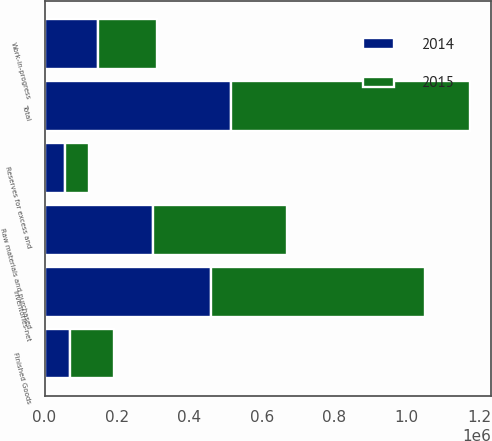Convert chart to OTSL. <chart><loc_0><loc_0><loc_500><loc_500><stacked_bar_chart><ecel><fcel>Raw materials and purchased<fcel>Work-in-progress<fcel>Finished Goods<fcel>Total<fcel>Reserves for excess and<fcel>Inventories-net<nl><fcel>2015<fcel>371073<fcel>164793<fcel>122956<fcel>658822<fcel>67421<fcel>591401<nl><fcel>2014<fcel>298318<fcel>146980<fcel>69658<fcel>514956<fcel>55882<fcel>459074<nl></chart> 